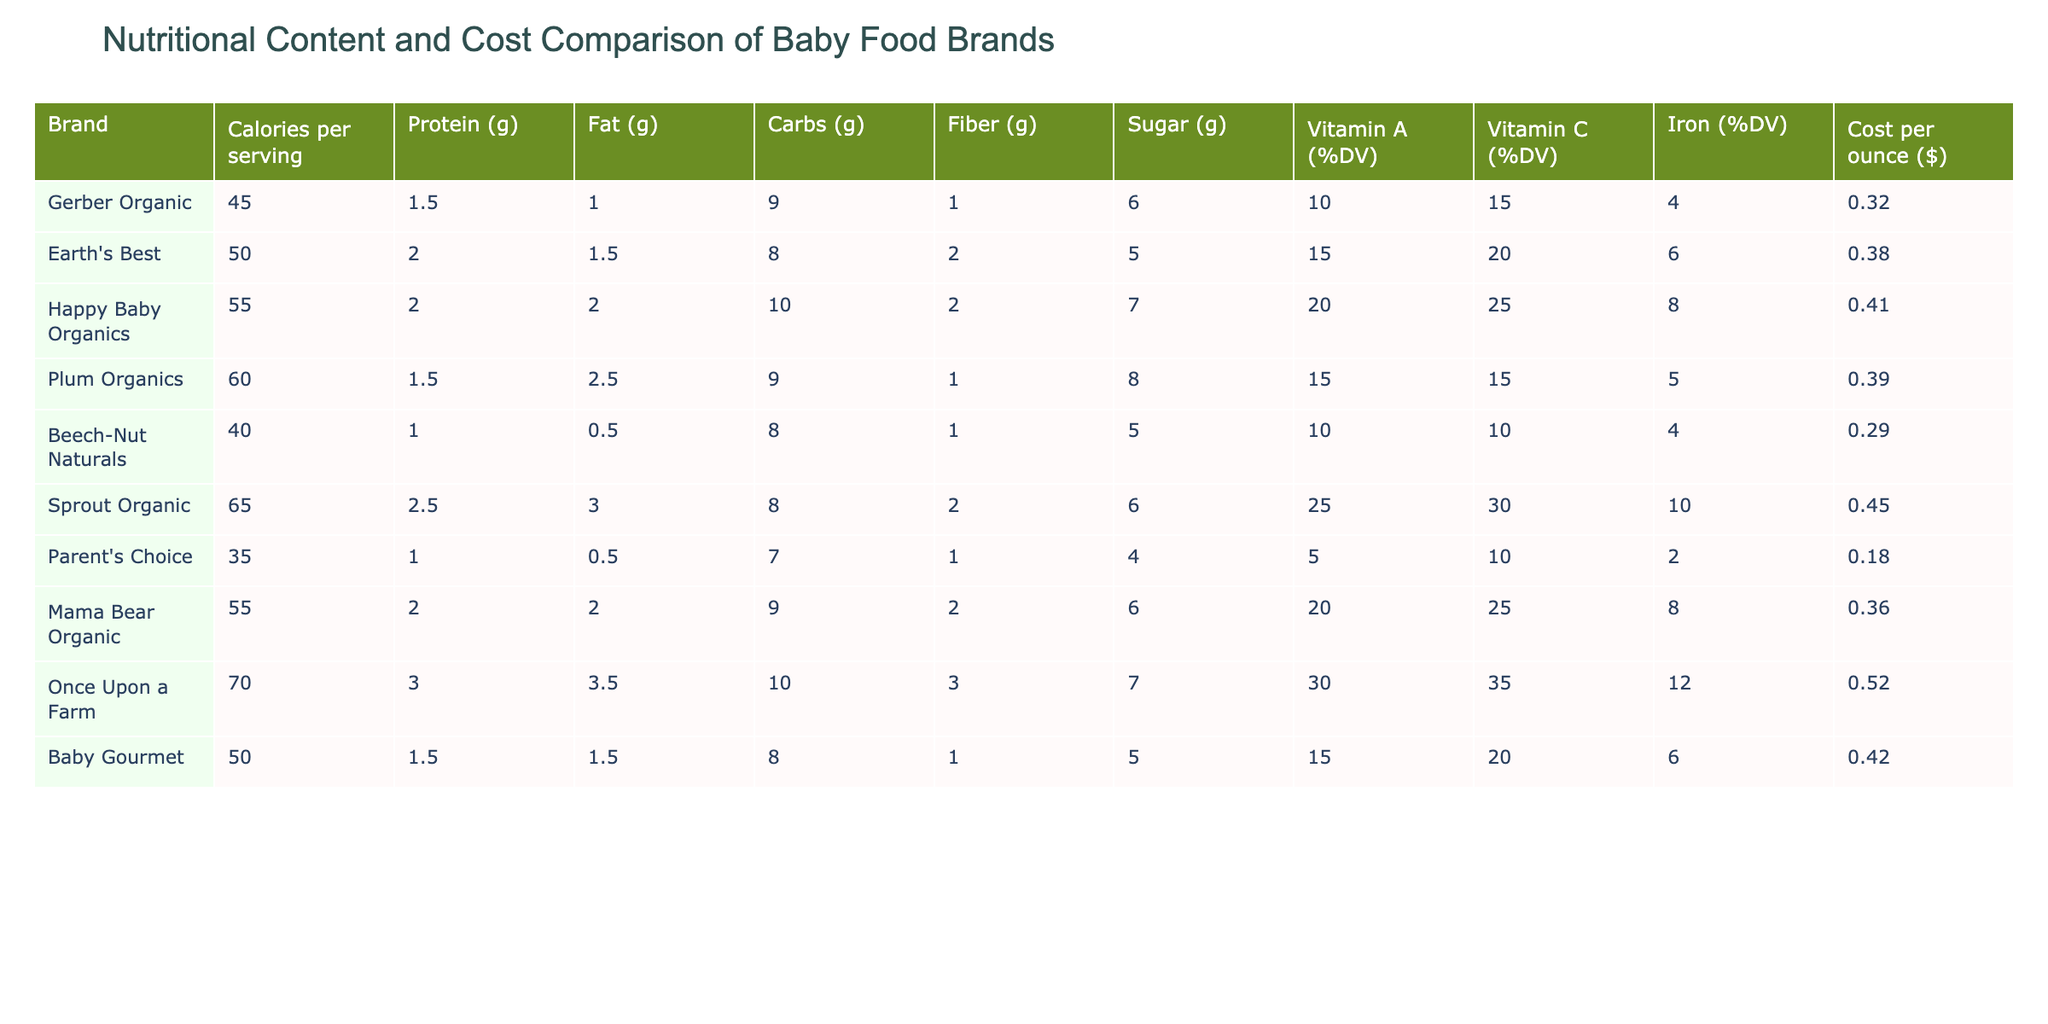What is the highest calorie baby food brand? By looking at the 'Calories per serving' column, we can see that the highest value is 70, which belongs to the brand Once Upon a Farm.
Answer: Once Upon a Farm Which brand has the lowest cost per ounce? Referring to the 'Cost per ounce' column, the minimum value is 0.18, which corresponds to Parent's Choice.
Answer: Parent's Choice How much protein does Happy Baby Organics provide per serving? The 'Protein (g)' column shows that Happy Baby Organics provides 2 grams of protein per serving.
Answer: 2 grams What is the difference in sugar content between Gerber Organic and Earth's Best? We subtract the sugar content of Gerber Organic (6 g) from Earth's Best (5 g). The difference is 6 - 5 = 1 g more in Gerber Organic.
Answer: 1 gram What is the average sugar content of all the brands? Adding up all the sugar content (6 + 5 + 7 + 8 + 5 + 6 + 4 + 6 + 7 + 5) gives a total of 59 grams. There are 10 brands, so the average is 59 / 10 = 5.9 grams per serving.
Answer: 5.9 grams Does any brand provide 3 grams of protein? Looking at the 'Protein (g)' column, only Once Upon a Farm has 3 grams of protein.
Answer: Yes Which brand has the highest Vitamin C percentage? The highest value in the 'Vitamin C (%DV)' column is 35%, found in Once Upon a Farm.
Answer: Once Upon a Farm What is the total fiber content in Sprout Organic compared to Beech-Nut Naturals? Sprout Organic contains 2 grams of fiber, while Beech-Nut Naturals contains 1 gram. The difference is 2 - 1 = 1 gram more in Sprout Organic.
Answer: 1 gram Can you find a brand that has both the lowest calories and cost per ounce? Checking the table shows that Parent's Choice has the lowest calories (35) and the lowest cost per ounce (0.18), confirming it meets both criteria.
Answer: Yes What is the total cost per ounce for the top three caloric brands? The brands with the highest calories are Once Upon a Farm (0.52), Happy Baby Organics (0.41), and Plum Organics (0.39). Adding these costs gives 0.52 + 0.41 + 0.39 = 1.32.
Answer: 1.32 